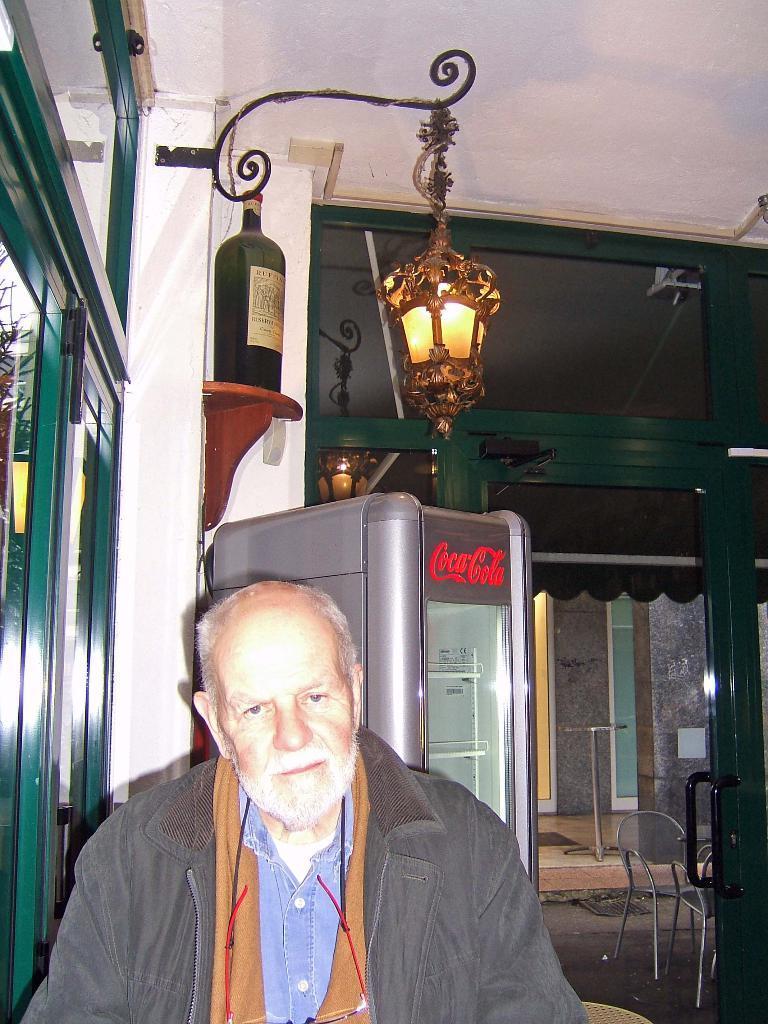How would you summarize this image in a sentence or two? In this picture we can see a man, behind to him we can see a bottle, light, refrigerator and few chairs. 